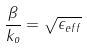Convert formula to latex. <formula><loc_0><loc_0><loc_500><loc_500>\frac { \beta } { k _ { o } } = \sqrt { \epsilon _ { e f f } }</formula> 